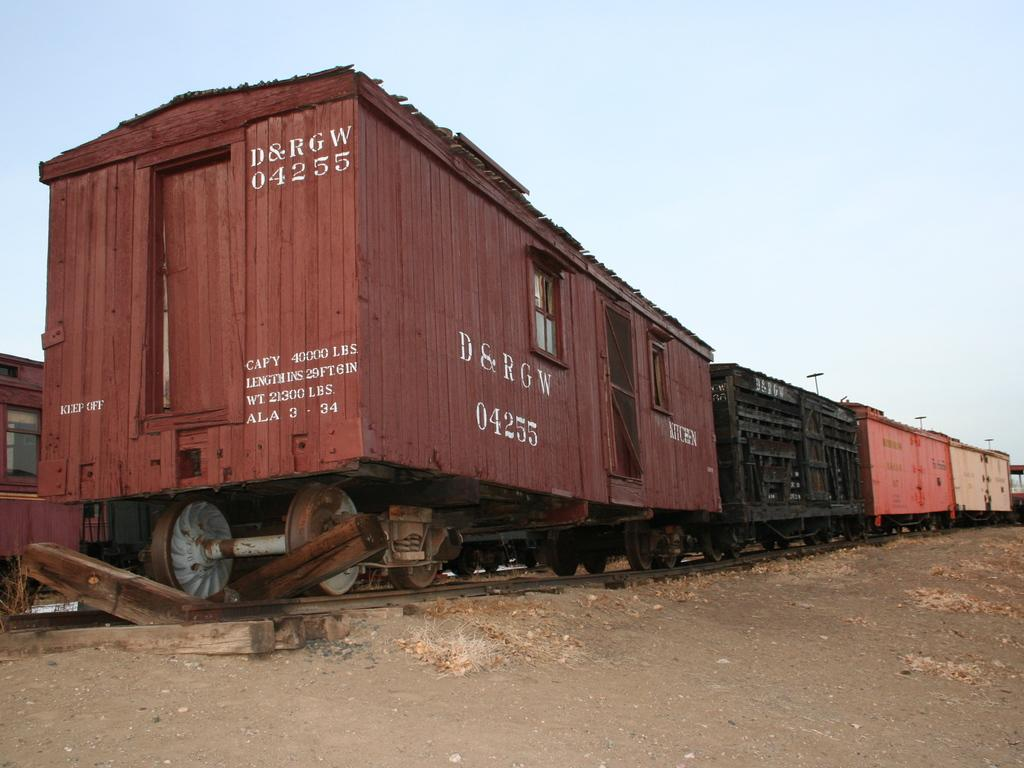<image>
Offer a succinct explanation of the picture presented. The back of a railroad car has the ID D&RGW 04255. 